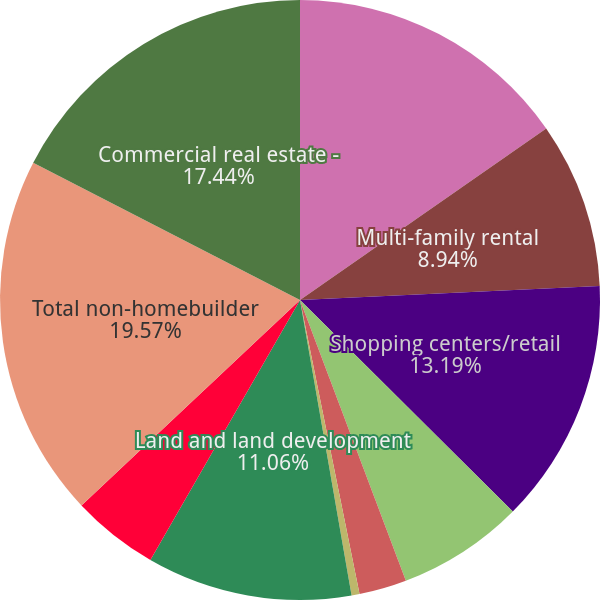Convert chart to OTSL. <chart><loc_0><loc_0><loc_500><loc_500><pie_chart><fcel>(Dollars in millions)<fcel>Multi-family rental<fcel>Shopping centers/retail<fcel>Industrial/warehouse<fcel>Multi-use<fcel>Hotels/motels<fcel>Land and land development<fcel>Other (3)<fcel>Total non-homebuilder<fcel>Commercial real estate -<nl><fcel>15.32%<fcel>8.94%<fcel>13.19%<fcel>6.81%<fcel>2.56%<fcel>0.43%<fcel>11.06%<fcel>4.68%<fcel>19.57%<fcel>17.44%<nl></chart> 